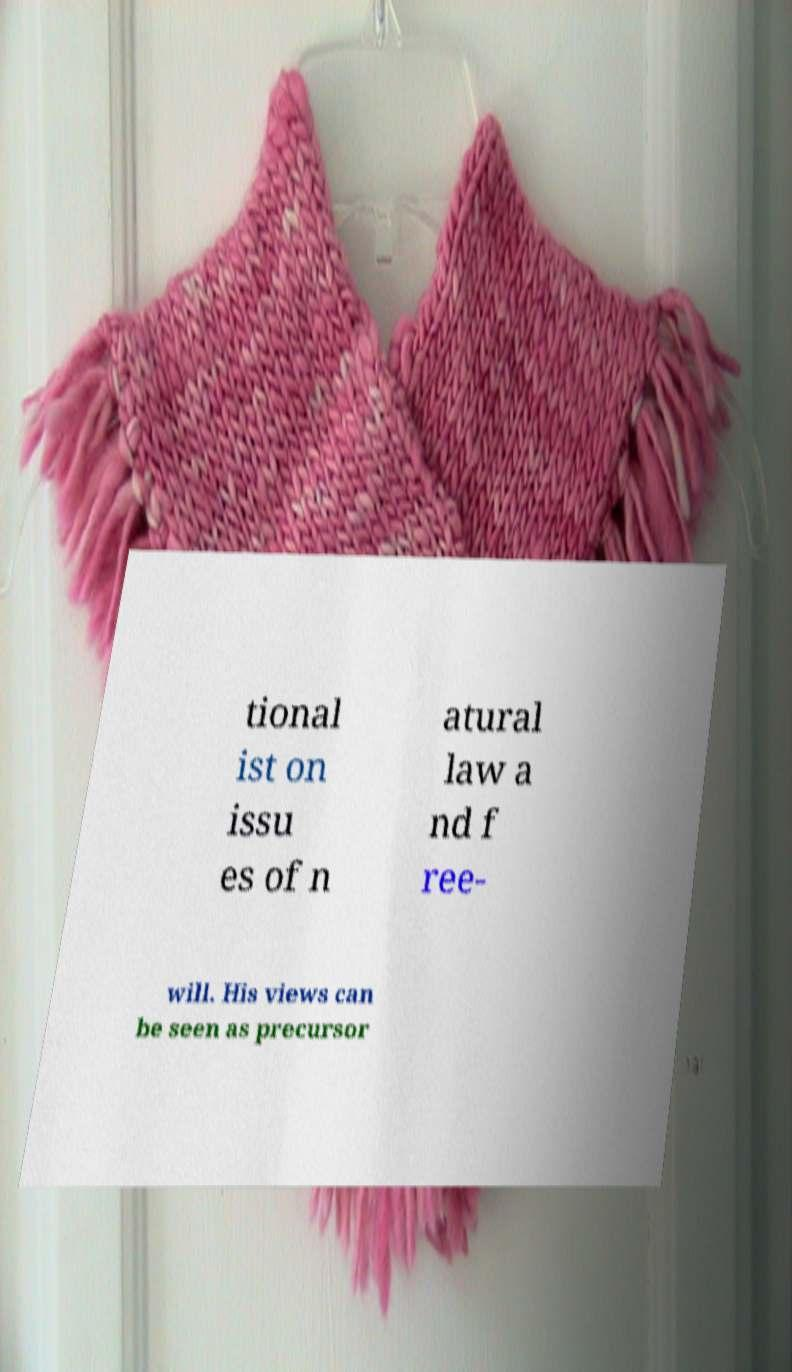For documentation purposes, I need the text within this image transcribed. Could you provide that? tional ist on issu es of n atural law a nd f ree- will. His views can be seen as precursor 